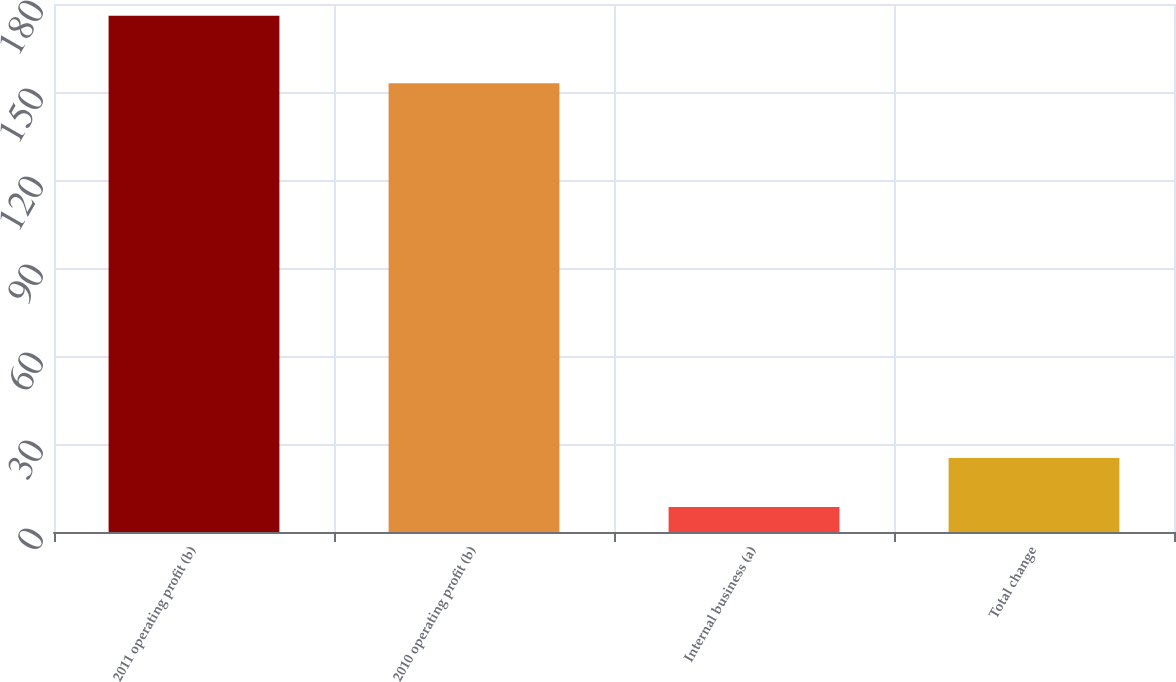Convert chart to OTSL. <chart><loc_0><loc_0><loc_500><loc_500><bar_chart><fcel>2011 operating profit (b)<fcel>2010 operating profit (b)<fcel>Internal business (a)<fcel>Total change<nl><fcel>176<fcel>153<fcel>8.5<fcel>25.25<nl></chart> 